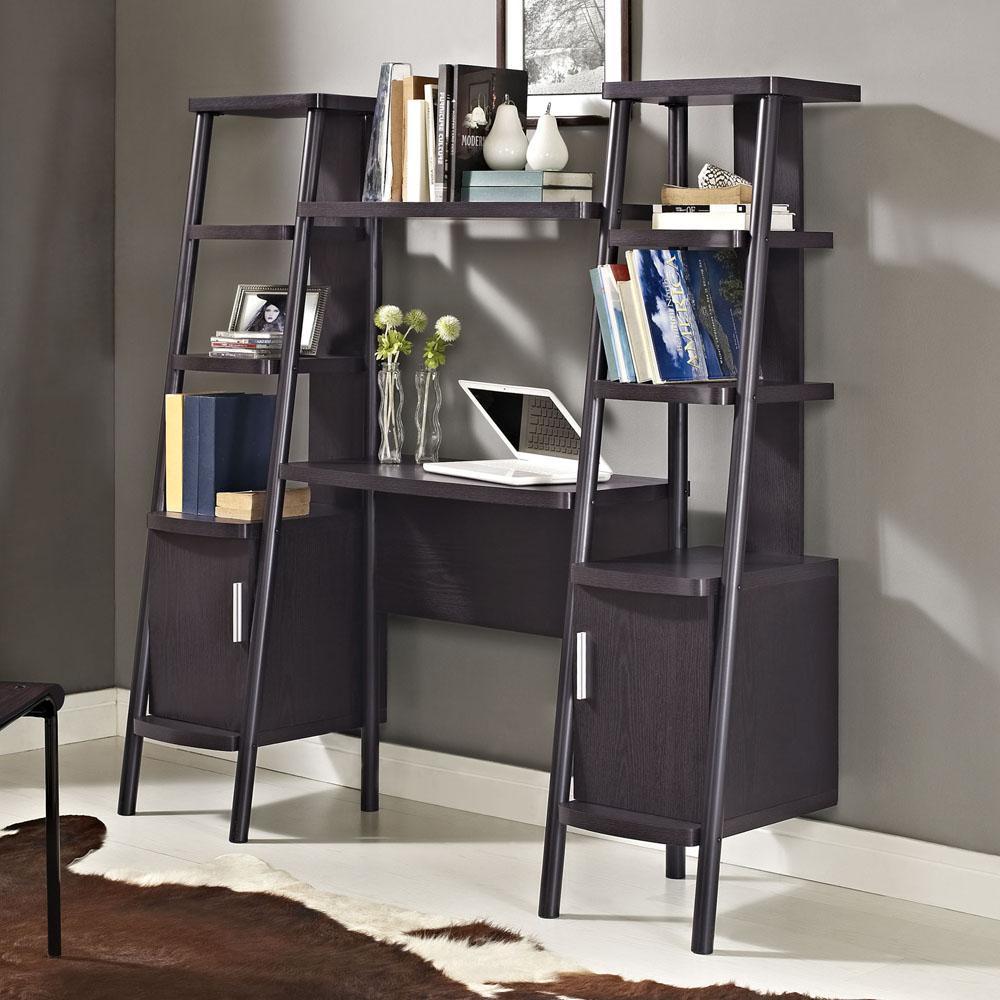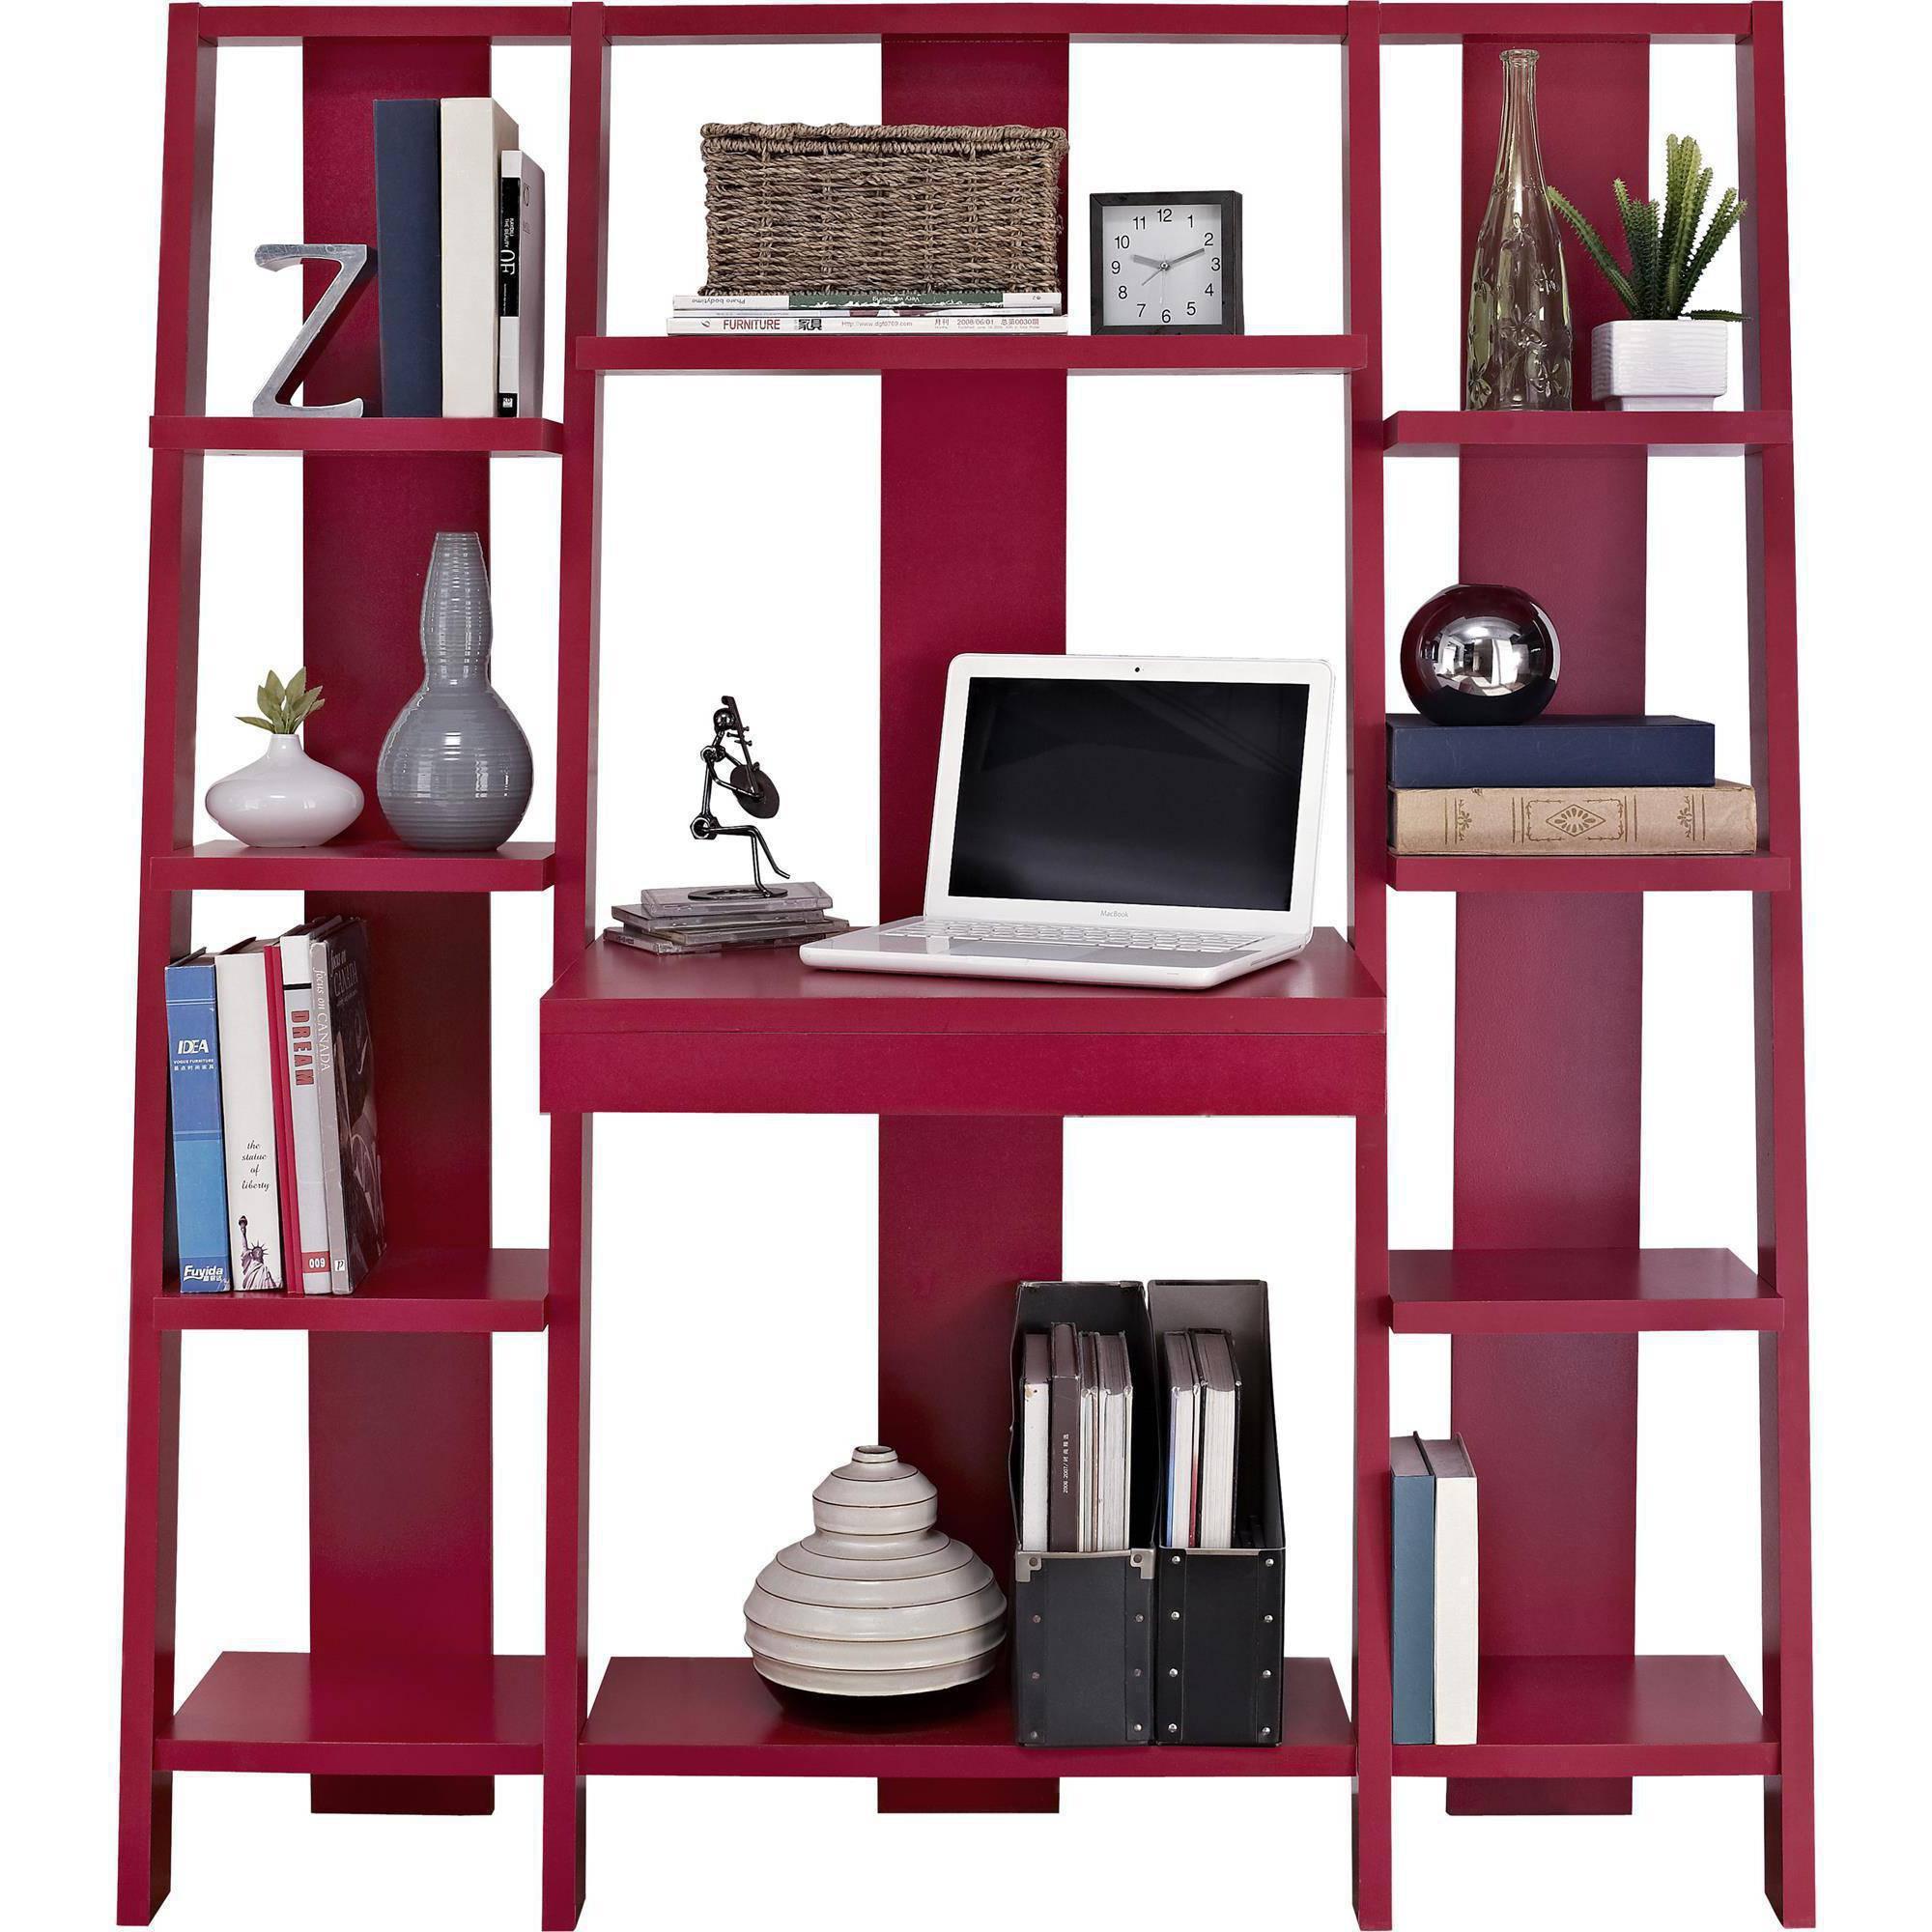The first image is the image on the left, the second image is the image on the right. Considering the images on both sides, is "The bookshelf on the right is burgundy in color and has a white laptop at its center, and the bookshelf on the left juts from the wall at an angle." valid? Answer yes or no. Yes. The first image is the image on the left, the second image is the image on the right. Considering the images on both sides, is "One wall unit is cherry brown." valid? Answer yes or no. Yes. 